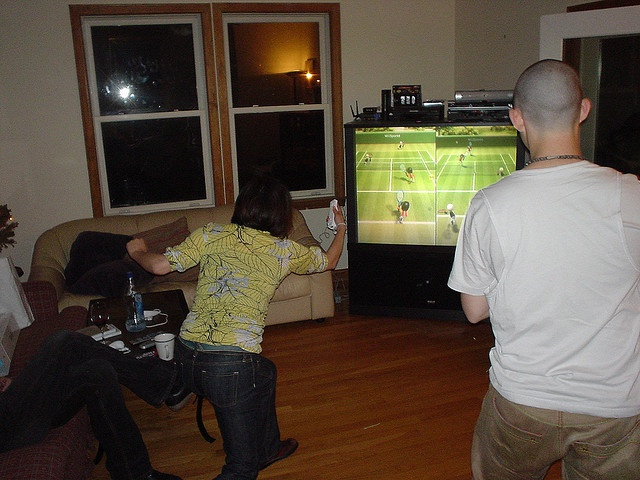Describe the objects in this image and their specific colors. I can see people in gray, darkgray, and lightgray tones, tv in gray, black, olive, and khaki tones, people in gray, black, and olive tones, people in gray, black, maroon, and darkgray tones, and couch in gray, black, and maroon tones in this image. 